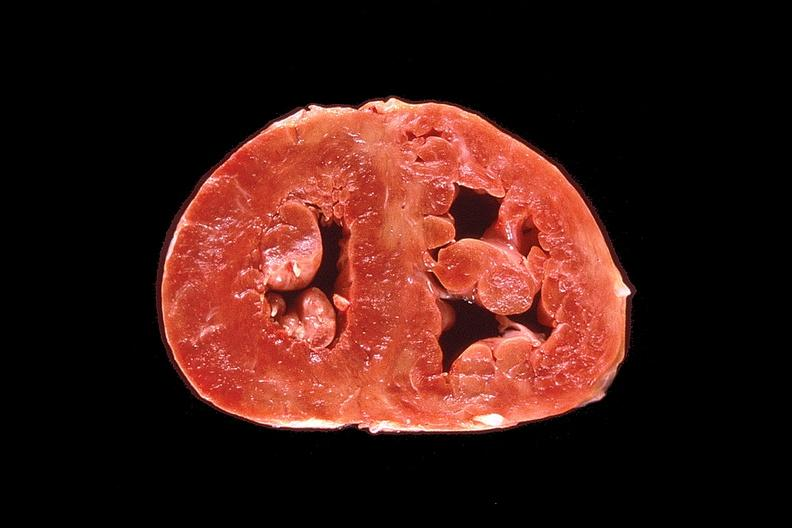does tuberculosis show heart, marked right ventricular hypertrophy due to pulmonary hypertension?
Answer the question using a single word or phrase. No 